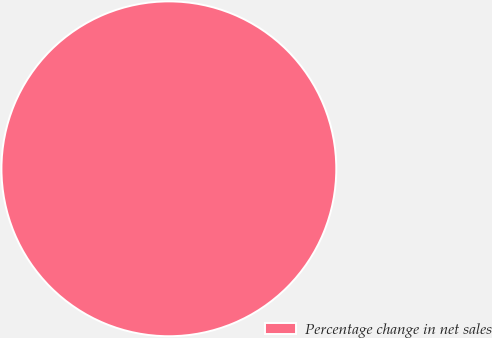<chart> <loc_0><loc_0><loc_500><loc_500><pie_chart><fcel>Percentage change in net sales<nl><fcel>100.0%<nl></chart> 